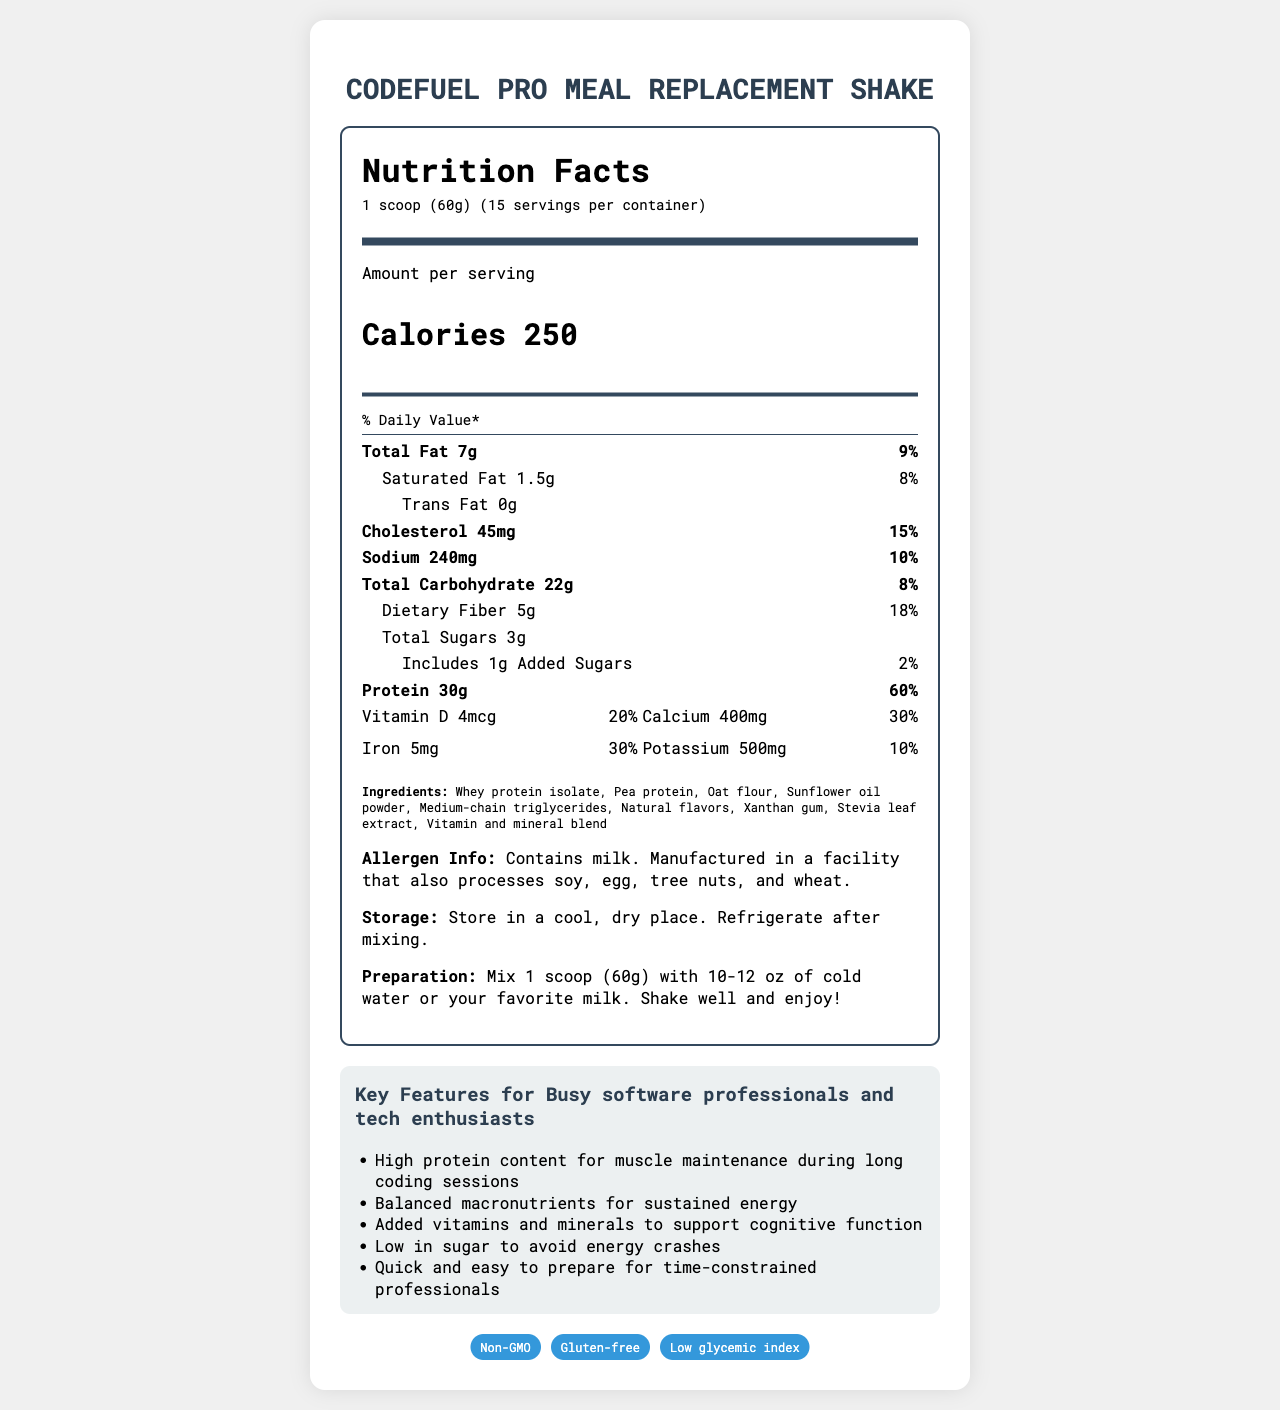what is the serving size of CodeFuel Pro Meal Replacement Shake? The serving size is listed at the top of the nutrition label as "1 scoop (60g)".
Answer: 1 scoop (60g) how many calories are in one serving of CodeFuel Pro Meal Replacement Shake? The number of calories per serving is specified as "Calories 250" in the main info section of the nutrition label.
Answer: 250 calories what percentage of daily value of protein does one serving provide? The protein content is listed as "Protein 30g," and the daily value percentage is "60%" next to it.
Answer: 60% what amount of dietary fiber is present in one serving? The dietary fiber amount is specified as "Dietary Fiber 5g" within the nutrient section of the nutrition label.
Answer: 5g name at least three key ingredients in the CodeFuel Pro Meal Replacement Shake. The ingredients are listed as "Whey protein isolate, Pea protein, Oat flour," among others in the ingredients section.
Answer: Whey protein isolate, Pea protein, Oat flour how many servings are there per container? The number of servings per container is mentioned as "15 servings per container" in the serving info section.
Answer: 15 when should the meal replacement shake be refrigerated? A. After opening B. After mixing C. Before mixing D. Never The storage instructions specify to "Refrigerate after mixing."
Answer: B which nutrient has the highest daily value percentage?  I. Total Fat II. Protein III. Vitamin A IV. Iron Protein has the highest daily value percentage at "60%", as listed in the nutrient section.
Answer: II is the product gluten-free? The document mentions that the product is "Gluten-free" under the certifications section.
Answer: Yes to which audience is the CodeFuel Pro Meal Replacement Shake targeted? The target audience is specified as "Busy software professionals and tech enthusiasts" near the end of the document.
Answer: Busy software professionals and tech enthusiasts how does the product support cognitive function? One of the key features is "Added vitamins and minerals to support cognitive function".
Answer: Added vitamins and minerals what makes this meal replacement shake low in sugar? The nutrition label indicates "Total Sugars 3g" and "Includes 1g Added Sugars (2%)", summarizing the low sugar content.
Answer: Total Sugars 3g, Includes 1g Added Sugars (2%) describe the main idea of the document. The document includes nutritional facts (calories, fats, proteins, vitamins, etc.), key features aimed at the target audience, ingredient list, allergen info, storage and preparation instructions, and certifications.
Answer: The document provides a detailed nutritional breakdown and key features of the CodeFuel Pro Meal Replacement Shake, highlighting its benefits for busy professionals, along with ingredient and allergen information. what is the ratio of calcium to iron in one serving? The nutrition label shows "Calcium 400mg" and "Iron 5mg", giving a ratio of 400:5.
Answer: 400mg of Calcium to 5mg of Iron does the product contain soy? The allergen info states it is manufactured in a facility that also processes soy, but it does not directly list soy among the ingredients.
Answer: Cannot be determined which certification is NOT listed on the document? A. Non-GMO B. Gluten-free C. Organic D. Low glycemic index The document lists "Non-GMO," "Gluten-free," and "Low glycemic index" as certifications, but does not mention "Organic."
Answer: C could someone allergic to tree nuts safely consume this product? The allergen info states the product is "Manufactured in a facility that also processes soy, egg, tree nuts, and wheat," posing a risk for someone with a tree nut allergy.
Answer: No what are the three fats-related nutrients listed? The nutrients listed related to fats are "Total Fat", "Saturated Fat", and "Trans Fat" in the nutrition label.
Answer: Total Fat, Saturated Fat, Trans Fat 